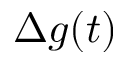<formula> <loc_0><loc_0><loc_500><loc_500>\Delta g ( t )</formula> 